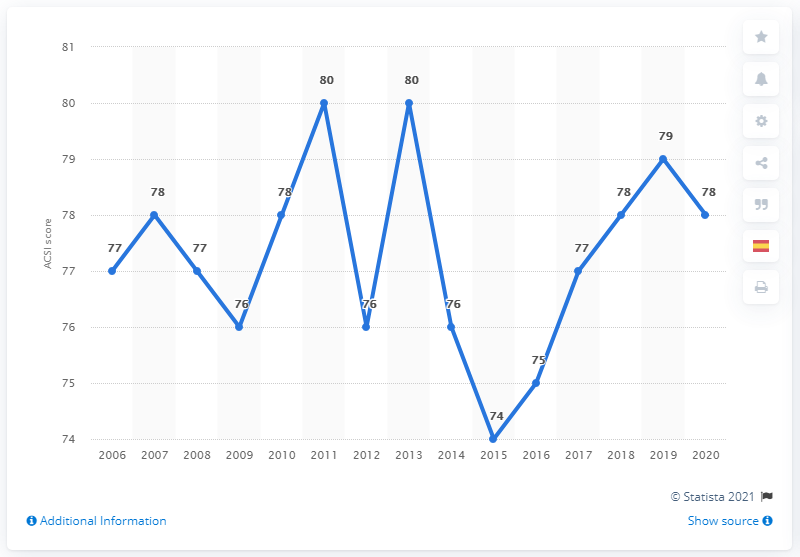Could you summarize the changes in Starbucks' ACSI scores in the last five years shown in the graph? Certainly! Looking at the last five years on the graph, there's been quite a journey in Starbucks' ACSI scores. Starting with a significant drop to 74 in 2015, there was a noticeable improvement in the following years up to 2018, where the score rose to 78. In 2019, it climbed further to a score of 79, suggesting an enhancement in customer satisfaction. However, in 2020, the score slightly dipped back to 78, indicating a slight decline but still remaining relatively high. 